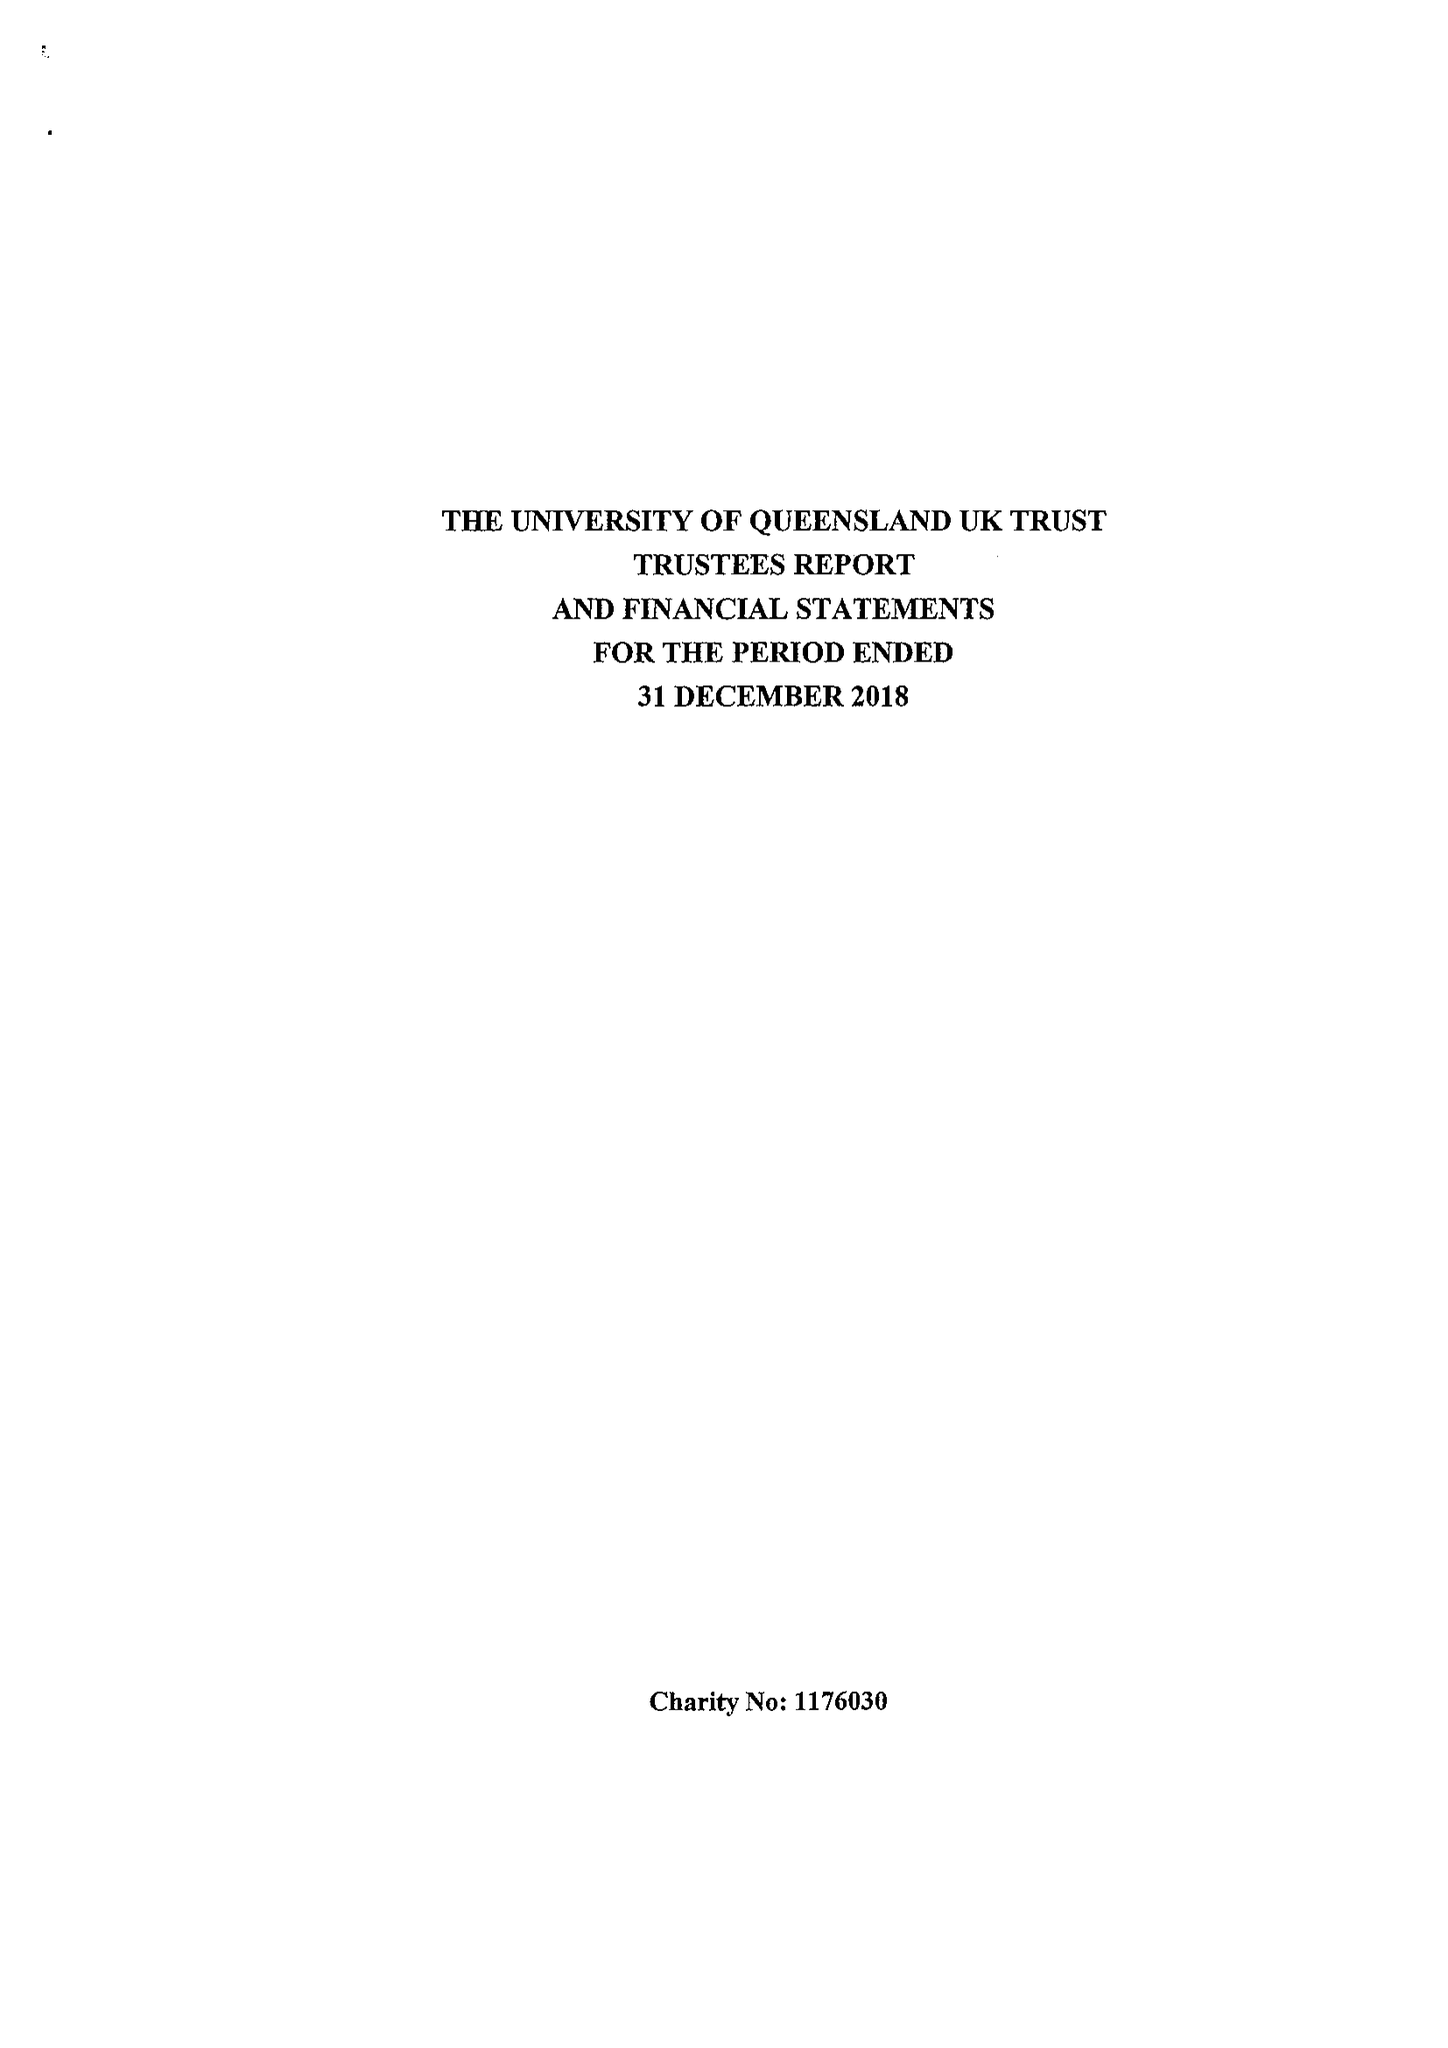What is the value for the spending_annually_in_british_pounds?
Answer the question using a single word or phrase. 7639.00 